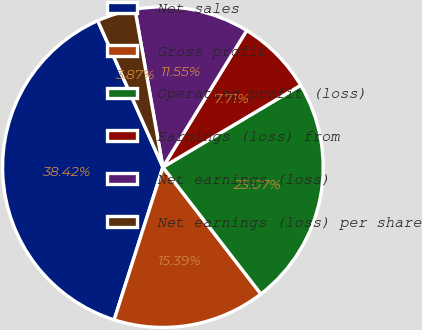Convert chart to OTSL. <chart><loc_0><loc_0><loc_500><loc_500><pie_chart><fcel>Net sales<fcel>Gross profit<fcel>Operating profit (loss)<fcel>Earnings (loss) from<fcel>Net earnings (loss)<fcel>Net earnings (loss) per share<nl><fcel>38.43%<fcel>15.39%<fcel>23.07%<fcel>7.71%<fcel>11.55%<fcel>3.87%<nl></chart> 